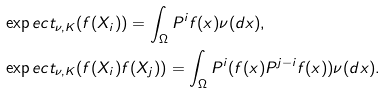<formula> <loc_0><loc_0><loc_500><loc_500>& \exp e c t _ { \nu , K } ( f ( X _ { i } ) ) = \int _ { \Omega } P ^ { i } f ( x ) \nu ( d x ) , \\ & \exp e c t _ { \nu , K } ( f ( X _ { i } ) f ( X _ { j } ) ) = \int _ { \Omega } P ^ { i } ( f ( x ) P ^ { j - i } f ( x ) ) \nu ( d x ) .</formula> 